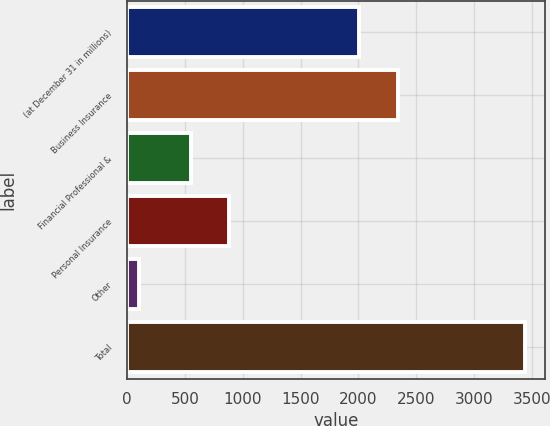<chart> <loc_0><loc_0><loc_500><loc_500><bar_chart><fcel>(at December 31 in millions)<fcel>Business Insurance<fcel>Financial Professional &<fcel>Personal Insurance<fcel>Other<fcel>Total<nl><fcel>2006<fcel>2339.2<fcel>551<fcel>884.2<fcel>106<fcel>3438<nl></chart> 